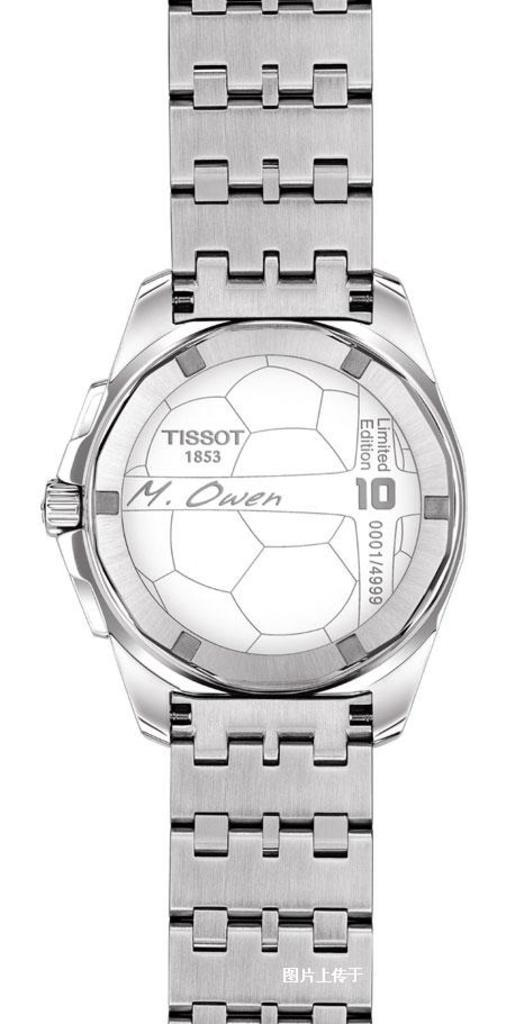<image>
Summarize the visual content of the image. A silver TISSOT 1853 M. Owen wrist watch. 